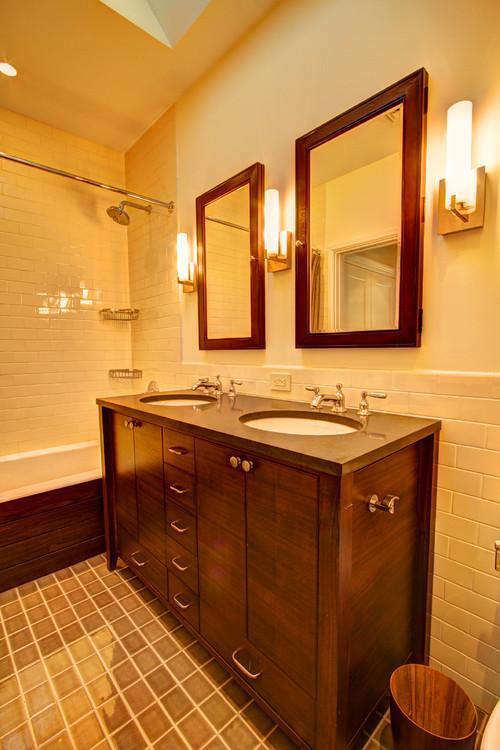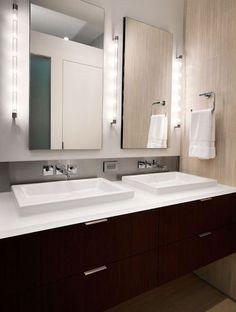The first image is the image on the left, the second image is the image on the right. Analyze the images presented: Is the assertion "One image contains a single sink over a cabinet on short legs with double doors, and the other image includes a long vanity with two inset white rectangular sinks." valid? Answer yes or no. No. The first image is the image on the left, the second image is the image on the right. Examine the images to the left and right. Is the description "In one image, a vanity the width of one sink has two doors and stands on short legs." accurate? Answer yes or no. No. 